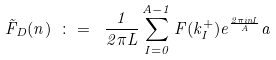Convert formula to latex. <formula><loc_0><loc_0><loc_500><loc_500>\tilde { F } _ { D } ( n ) \ \colon = \ \frac { 1 } { 2 \pi L } \sum _ { I = 0 } ^ { A - 1 } F ( k _ { I } ^ { + } ) e ^ { \frac { 2 \pi i n I } { A } } a</formula> 